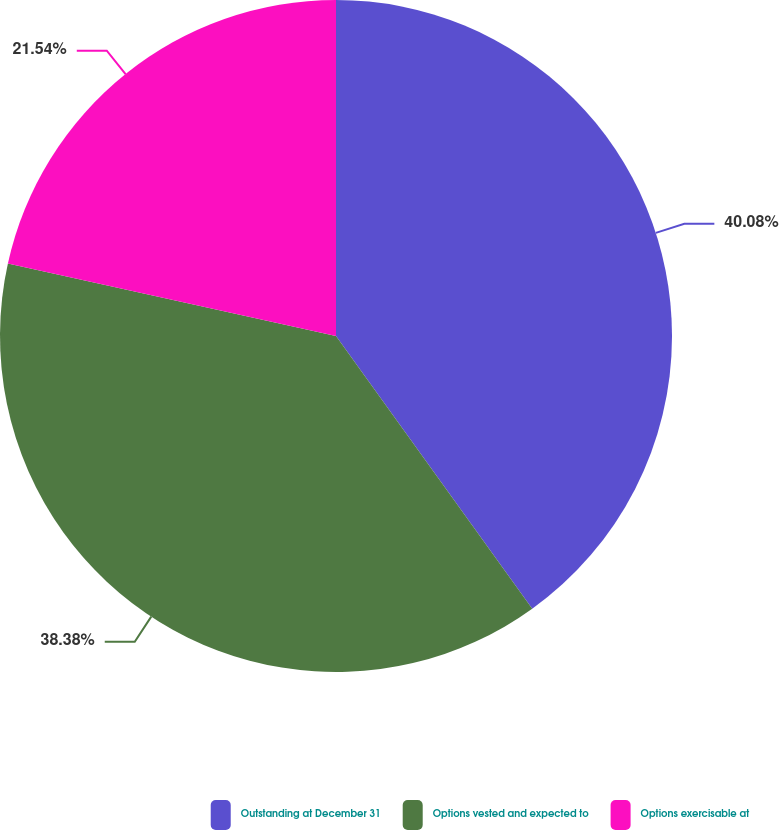Convert chart. <chart><loc_0><loc_0><loc_500><loc_500><pie_chart><fcel>Outstanding at December 31<fcel>Options vested and expected to<fcel>Options exercisable at<nl><fcel>40.07%<fcel>38.38%<fcel>21.54%<nl></chart> 